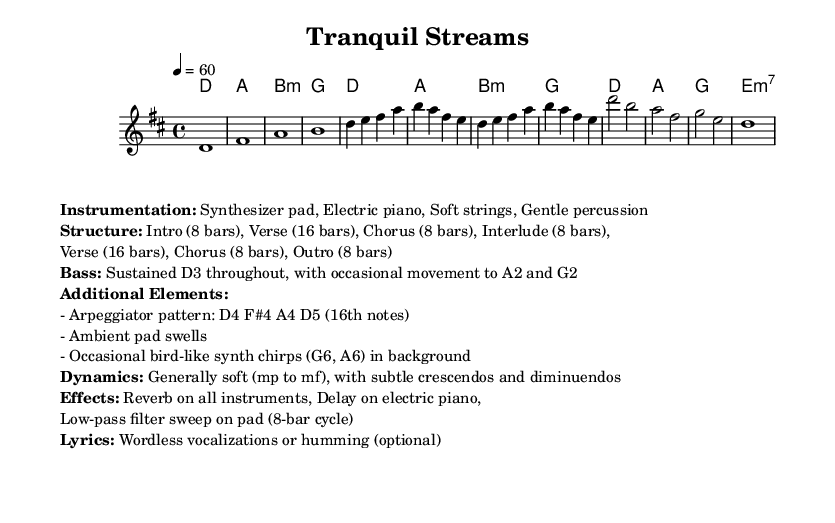What is the key signature of this music? The key signature shows one sharp, which is an F#, indicating it is in D major.
Answer: D major What is the time signature of the piece? The time signature is found at the beginning of the score, indicating four beats per measure, or 4/4.
Answer: 4/4 What is the tempo marking of this piece? The tempo marking indicates that the piece should be played at a speed of 60 beats per minute.
Answer: 60 How many bars are in the Intro section? The Intro section is specified as having 8 bars, as indicated in the structure outlined in the markup.
Answer: 8 bars What instruments are used in this composition? The instrumentation is listed in the markup, which includes a synthesizer pad, electric piano, soft strings, and gentle percussion.
Answer: Synthesizer pad, Electric piano, Soft strings, Gentle percussion What is the primary dynamic range of the piece? The dynamics are noted to generally be soft, ranging from mezzo-piano to mezzo-forte, with subtle changes.
Answer: mp to mf How does the bass part primarily function in this piece? The bass is indicated to sustain a D note throughout and occasionally move to an A and G, providing a grounding presence in the music.
Answer: Sustained D3, with movement to A2 and G2 